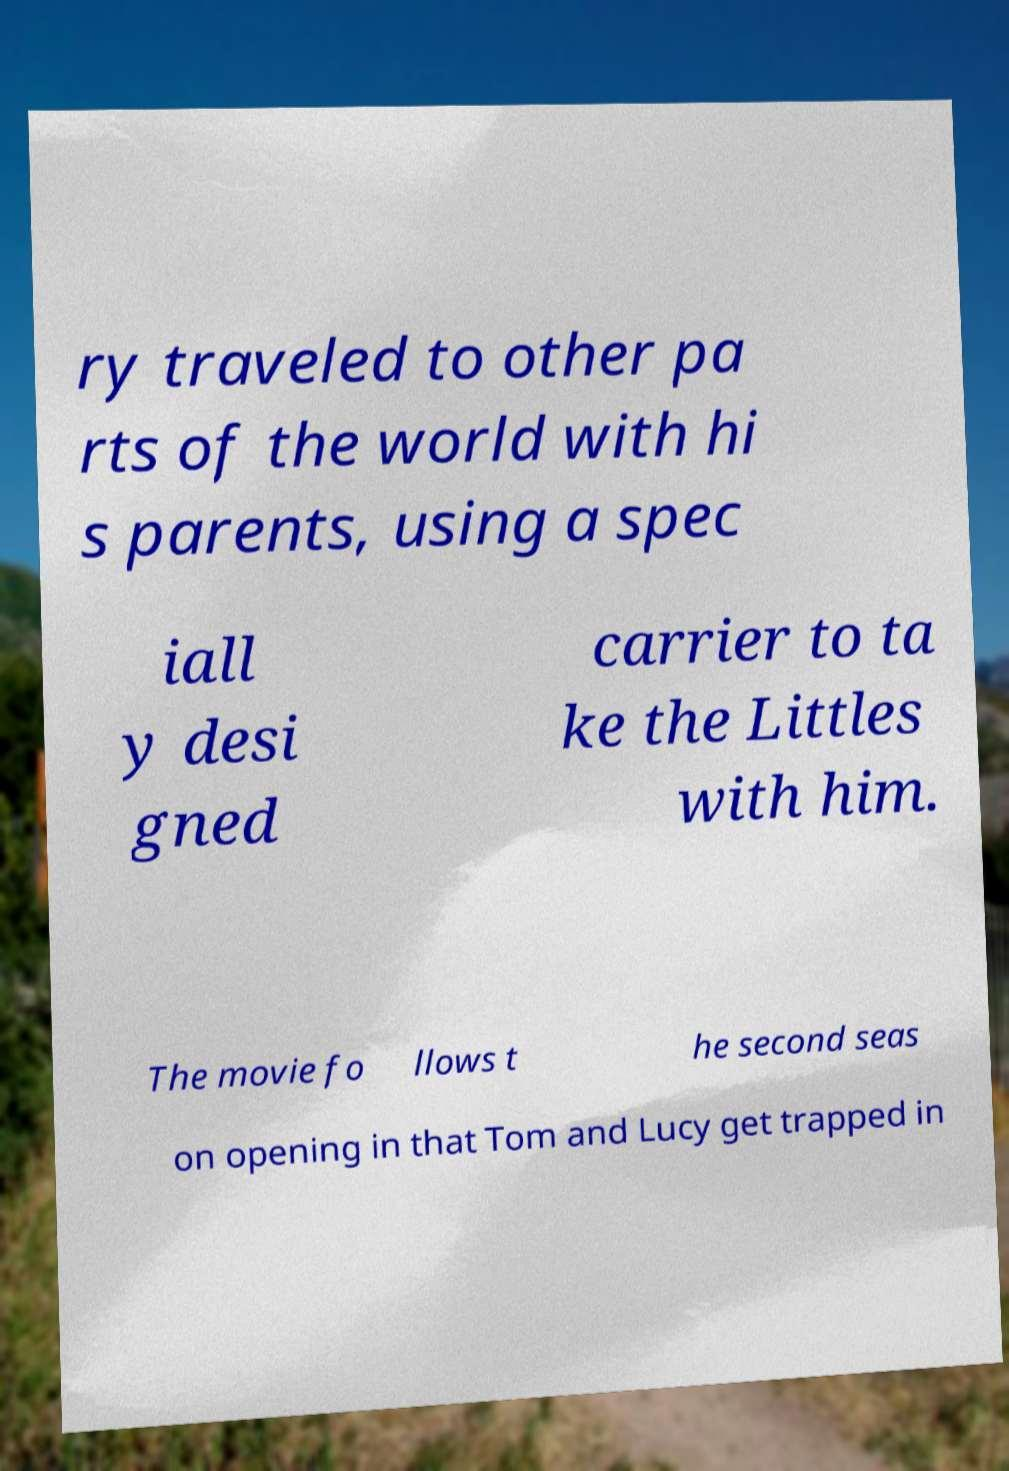Could you extract and type out the text from this image? ry traveled to other pa rts of the world with hi s parents, using a spec iall y desi gned carrier to ta ke the Littles with him. The movie fo llows t he second seas on opening in that Tom and Lucy get trapped in 